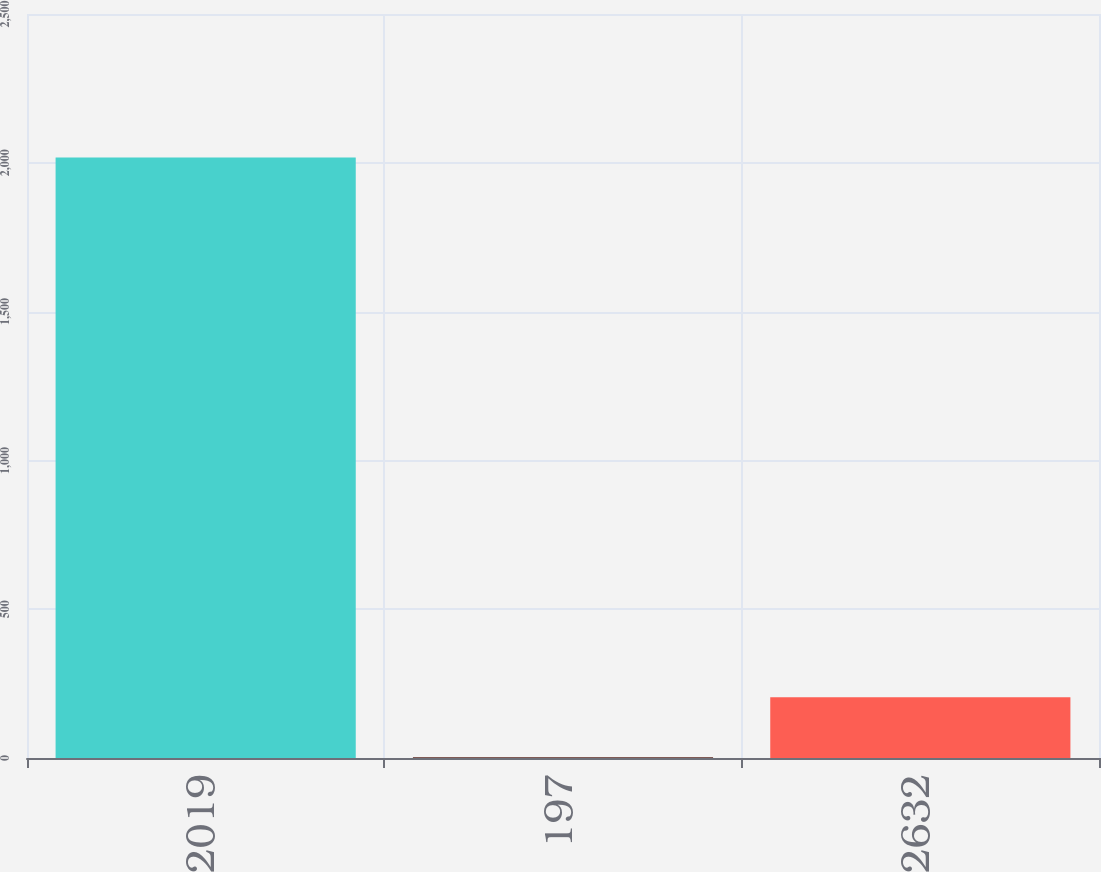<chart> <loc_0><loc_0><loc_500><loc_500><bar_chart><fcel>2019<fcel>197<fcel>2632<nl><fcel>2018<fcel>2.25<fcel>203.83<nl></chart> 